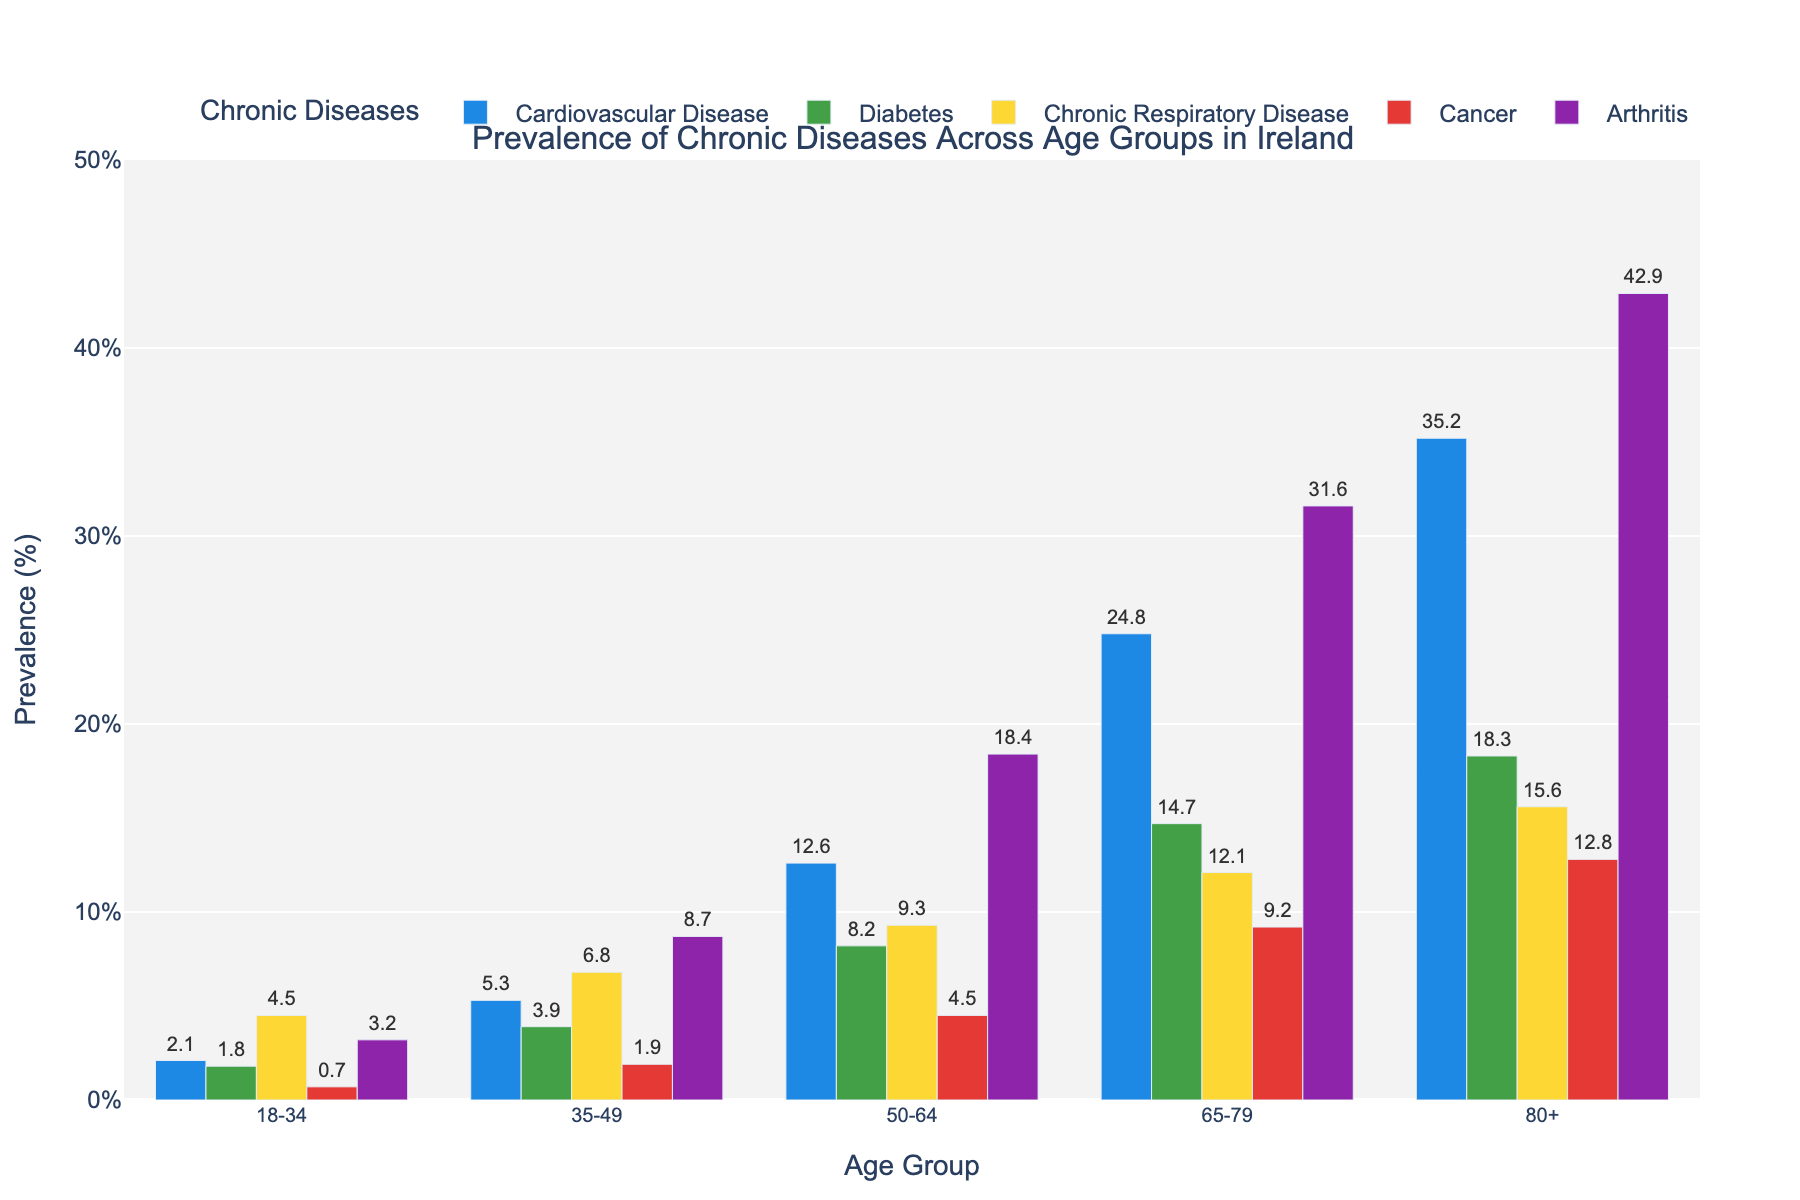Which age group has the highest prevalence of cardiovascular disease? The height of the bars represents the prevalence. The highest bar for cardiovascular disease is in the 80+ age group.
Answer: 80+ Which chronic disease has the lowest prevalence in the 35-49 age group? By looking at the different colored bars for each disease within the 35-49 age group, cancer has the lowest bar height.
Answer: Cancer What is the difference in prevalence of arthritis between the 50-64 and 65-79 age groups? The bar height for arthritis in the 50-64 age group is 18.4, and for the 65-79 age group, it is 31.6. The difference is 31.6 - 18.4.
Answer: 13.2 Which chronic disease shows a consistent increase in prevalence across all age groups? Reviewing each disease’s bars across the age groups, cardiovascular disease's bars increase consistently from 18-34 to 80+.
Answer: Cardiovascular Disease Compare the prevalence of diabetes in the 65-79 age group to that in the 80+ age group. The bar height for diabetes in the 65-79 age group is 14.7, whereas in the 80+ age group it is 18.3.
Answer: Higher in the 80+ group In the 18-34 age group, which disease has approximately twice the prevalence of cancer? The cancer bar's height in the 18-34 age group is 0.7. The disease with approximately double that prevalence is chronic respiratory disease, with a height of 4.5, which is more than double.
Answer: Chronic Respiratory Disease Calculate the average prevalence of cancer across all age groups. Sum the values of cancer prevalence (0.7, 1.9, 4.5, 9.2, 12.8) and divide by the number of age groups (5). (0.7 + 1.9 + 4.5 + 9.2 + 12.8)/5
Answer: 5.82 Which age group has the smallest difference in prevalence between cardiovascular disease and diabetes? Calculate the differences for each age group: 18-34 (2.1 - 1.8 = 0.3), 35-49 (5.3 - 3.9 = 1.4), 50-64 (12.6 - 8.2 = 4.4), 65-79 (24.8 - 14.7 = 10.1), 80+ (35.2 - 18.3 = 16.9). The smallest difference is for 18-34 with 0.3.
Answer: 18-34 What is the sum of the prevalence of chronic respiratory disease across all age groups? Sum the values of chronic respiratory disease prevalence (4.5, 6.8, 9.3, 12.1, 15.6). 4.5 + 6.8 + 9.3 + 12.1 + 15.6
Answer: 48.3 